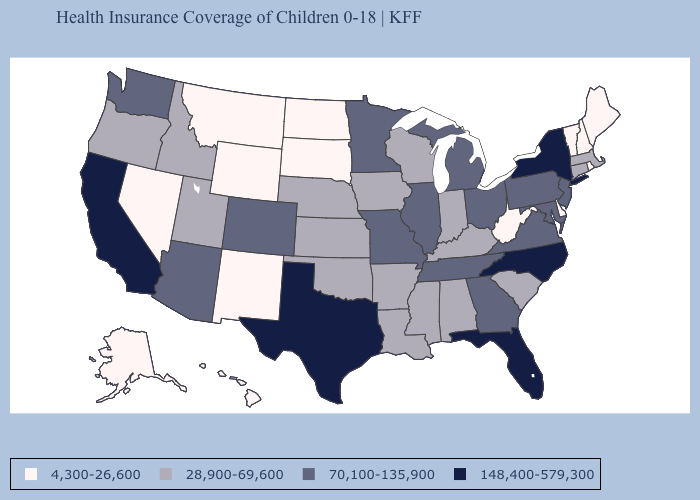Which states have the lowest value in the Northeast?
Concise answer only. Maine, New Hampshire, Rhode Island, Vermont. Does Alaska have the lowest value in the West?
Answer briefly. Yes. Name the states that have a value in the range 148,400-579,300?
Short answer required. California, Florida, New York, North Carolina, Texas. Which states have the lowest value in the USA?
Be succinct. Alaska, Delaware, Hawaii, Maine, Montana, Nevada, New Hampshire, New Mexico, North Dakota, Rhode Island, South Dakota, Vermont, West Virginia, Wyoming. Which states hav the highest value in the MidWest?
Be succinct. Illinois, Michigan, Minnesota, Missouri, Ohio. Name the states that have a value in the range 70,100-135,900?
Concise answer only. Arizona, Colorado, Georgia, Illinois, Maryland, Michigan, Minnesota, Missouri, New Jersey, Ohio, Pennsylvania, Tennessee, Virginia, Washington. Does Louisiana have the highest value in the USA?
Short answer required. No. Among the states that border New York , which have the highest value?
Answer briefly. New Jersey, Pennsylvania. Name the states that have a value in the range 28,900-69,600?
Give a very brief answer. Alabama, Arkansas, Connecticut, Idaho, Indiana, Iowa, Kansas, Kentucky, Louisiana, Massachusetts, Mississippi, Nebraska, Oklahoma, Oregon, South Carolina, Utah, Wisconsin. What is the value of Massachusetts?
Short answer required. 28,900-69,600. Does North Dakota have the lowest value in the MidWest?
Concise answer only. Yes. Name the states that have a value in the range 70,100-135,900?
Give a very brief answer. Arizona, Colorado, Georgia, Illinois, Maryland, Michigan, Minnesota, Missouri, New Jersey, Ohio, Pennsylvania, Tennessee, Virginia, Washington. Does South Carolina have the lowest value in the South?
Write a very short answer. No. Among the states that border Delaware , which have the highest value?
Be succinct. Maryland, New Jersey, Pennsylvania. Does Iowa have the same value as Nebraska?
Quick response, please. Yes. 